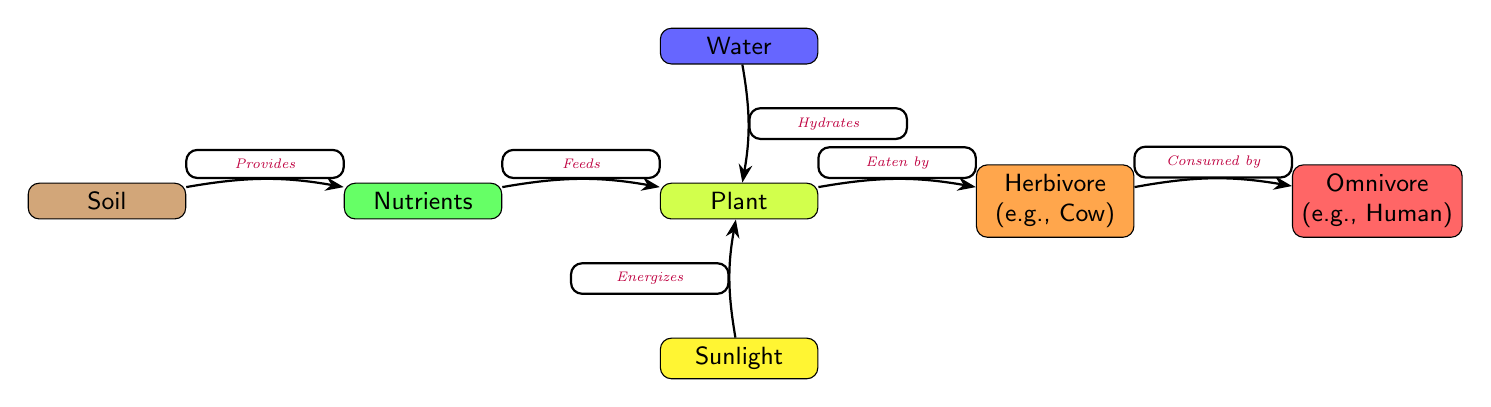What is the first node in the flow? The first node in the diagram represents the starting point of the nutrient flow, which is labeled "Soil."
Answer: Soil How many nodes are represented in the diagram? By counting the individual components represented as nodes, there are a total of 7 nodes, including Soil, Nutrients, Plant, Water, Sunlight, Herbivore, and Omnivore.
Answer: 7 What does the Soil provide? According to the diagram, the relationship shows that Soil provides "Nutrients" to the next node.
Answer: Nutrients What is the function of Sunlight in this food chain? The diagram specifies that Sunlight "Energizes" the Plant, indicating its role in the nutrient cycle.
Answer: Energizes Who consumes the Herbivore? The flow of the diagram indicates that the Omnivore is the one that consumes the Herbivore, showing the interaction between these two nodes.
Answer: Omnivore What do Nutrients do in the food chain? According to the diagram, Nutrients "Feeds" the Plant, highlighting their direct role in supporting plant growth.
Answer: Feeds What must be present alongside the Nutrients for the Plant to thrive? The diagram shows that both Water and Sunlight are essential for the Plant, indicating multiple sources needed for plant health.
Answer: Water and Sunlight Which node does the Plant connect to next? The diagram illustrates that the Plant connects directly to the Herbivore, indicating it is the next consumer in the food chain.
Answer: Herbivore Why is Soil important in this food chain? The diagram identifies Soil as the source of Nutrients, which are critical for Plant growth and the subsequent feeding of Herbivores and Omnivores, establishing the foundational role of Soil in the nutrient flow.
Answer: Provides Nutrients 